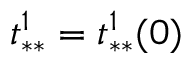<formula> <loc_0><loc_0><loc_500><loc_500>t _ { * * } ^ { 1 } = t _ { * * } ^ { 1 } ( 0 )</formula> 